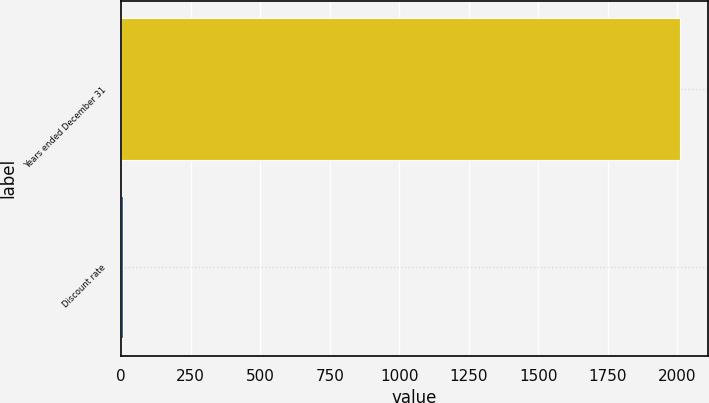Convert chart to OTSL. <chart><loc_0><loc_0><loc_500><loc_500><bar_chart><fcel>Years ended December 31<fcel>Discount rate<nl><fcel>2008<fcel>6<nl></chart> 